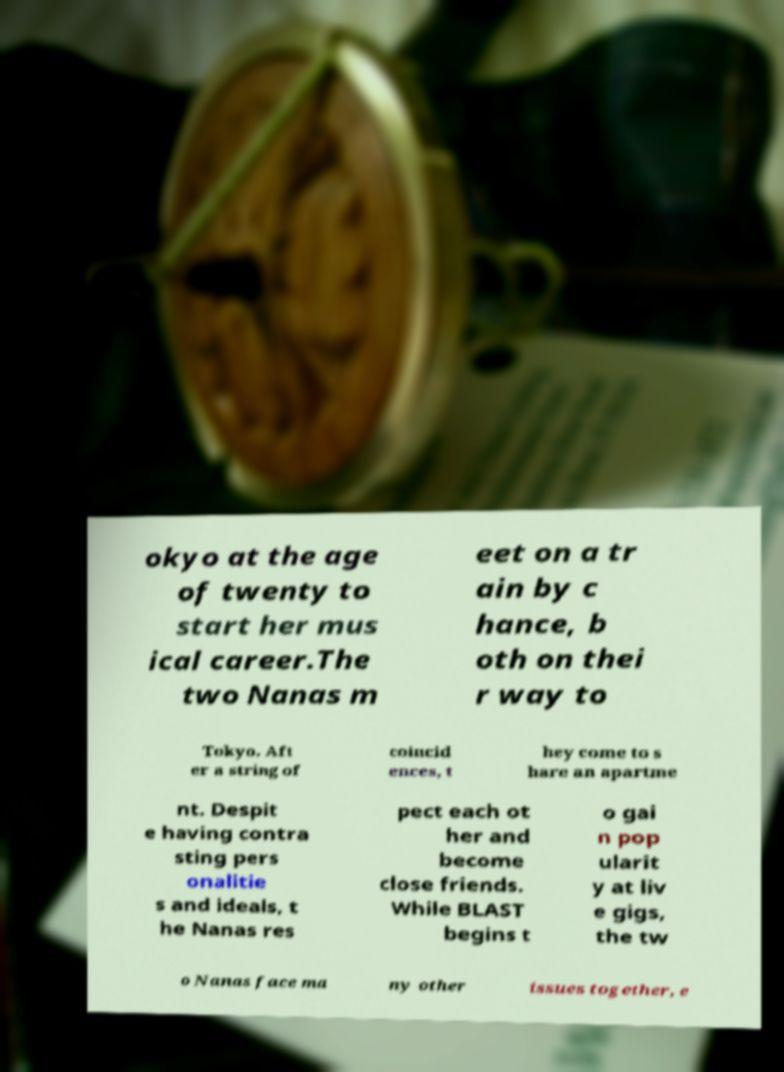I need the written content from this picture converted into text. Can you do that? okyo at the age of twenty to start her mus ical career.The two Nanas m eet on a tr ain by c hance, b oth on thei r way to Tokyo. Aft er a string of coincid ences, t hey come to s hare an apartme nt. Despit e having contra sting pers onalitie s and ideals, t he Nanas res pect each ot her and become close friends. While BLAST begins t o gai n pop ularit y at liv e gigs, the tw o Nanas face ma ny other issues together, e 